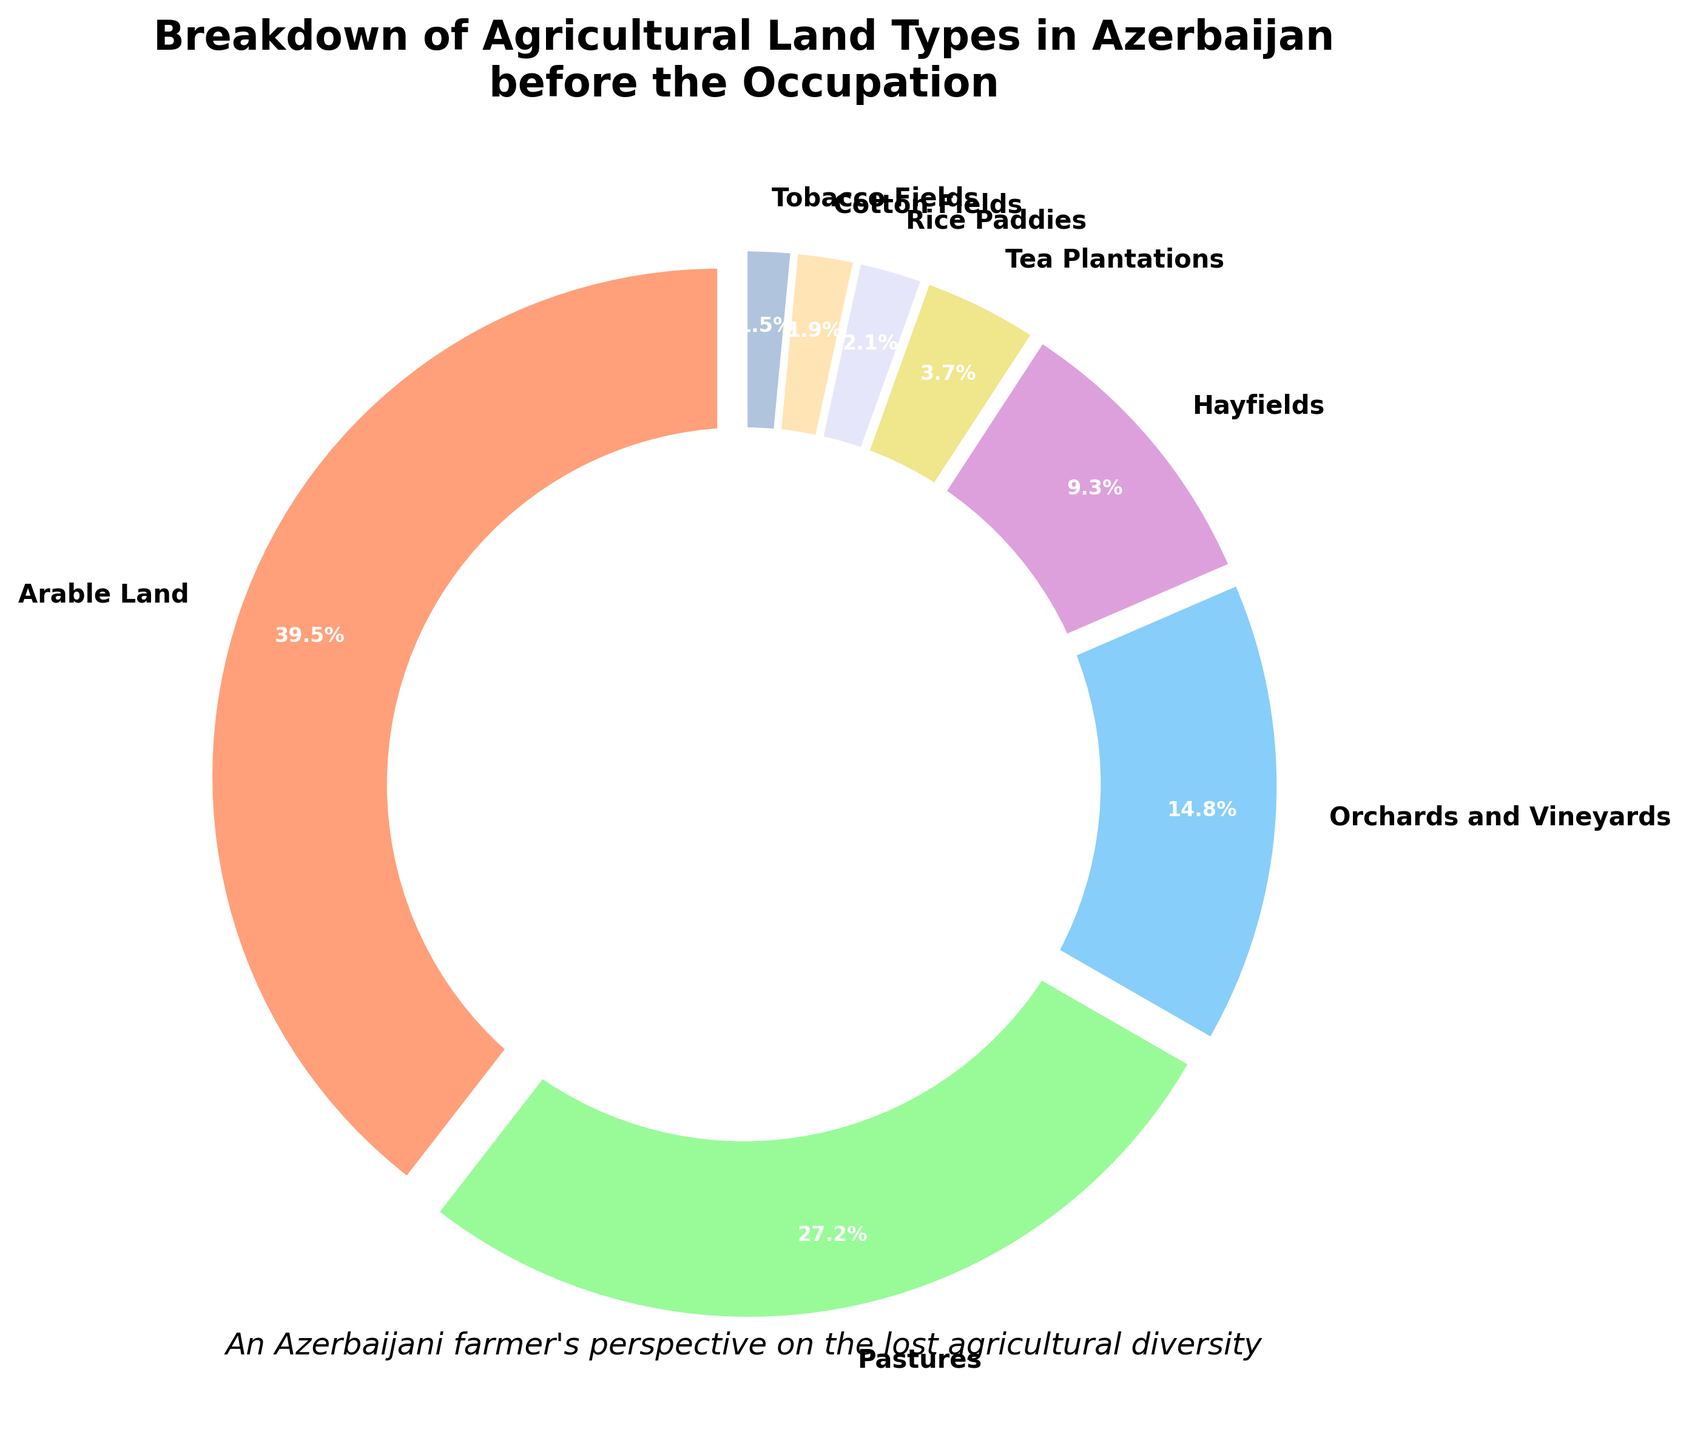Which land type occupies the largest percentage of agricultural land? The figure shows different types of agricultural land with their respective percentages. The largest portion is represented by "Arable Land," which occupies 39.5%.
Answer: Arable Land Which land types together make up more than 50% of the agricultural land? Adding the percentages of the largest categories: Arable Land (39.5%), Pastures (27.2%), and Orchards and Vineyards (14.8%) gives a sum of 81.5%, which is more than 50%.
Answer: Arable Land and Pastures How much larger is the percentage of Arable Land than Hayfields? The percentage of Arable Land is 39.5% and Hayfields is 9.3%. Subtracting these gives: 39.5% - 9.3% = 30.2%.
Answer: 30.2% What is the combined percentage of the smallest three land types? The smallest three land types are Rice Paddies (2.1%), Cotton Fields (1.9%), and Tobacco Fields (1.5%). Adding these gives: 2.1% + 1.9% + 1.5% = 5.5%.
Answer: 5.5% Which land type occupies less percentage than Tea Plantations but more than Cotton Fields? Tea Plantations occupy 3.7% and Cotton Fields occupy 1.9%. The land type falling between these percentages is Rice Paddies, which occupy 2.1%.
Answer: Rice Paddies Are there more pastures or orchards and vineyards? The chart shows Pastures at 27.2% and Orchards and Vineyards at 14.8%, indicating that there are more pastures.
Answer: Pastures What is the average percentage of Tobacco Fields, Cotton Fields, and Tea Plantations? Adding the percentages: 1.5% (Tobacco Fields) + 1.9% (Cotton Fields) + 3.7% (Tea Plantations) = 7.1%. There are 3 types, so the average is 7.1% / 3 = 2.37%.
Answer: 2.37% Which two land types combined have a percentage similar to Arable Land? Arable Land is 39.5%. Combining Pastures (27.2%) and Orchards and Vineyards (14.8%) gives: 27.2% + 14.8% = 42%, which is fairly close to 39.5%.
Answer: Pastures and Orchards and Vineyards Which land type occupies nearly the same space as Hayfields and Tea Plantations combined? Hayfields (9.3%) and Tea Plantations (3.7%) combined are: 9.3% + 3.7% = 13%. Orchards and Vineyards occupy 14.8%, which is a close match.
Answer: Orchards and Vineyards What color represents Tobacco Fields in the pie chart? The colors applied to each sector are distinct. Tobacco Fields are represented by the color blue (the last color listed).
Answer: Blue 